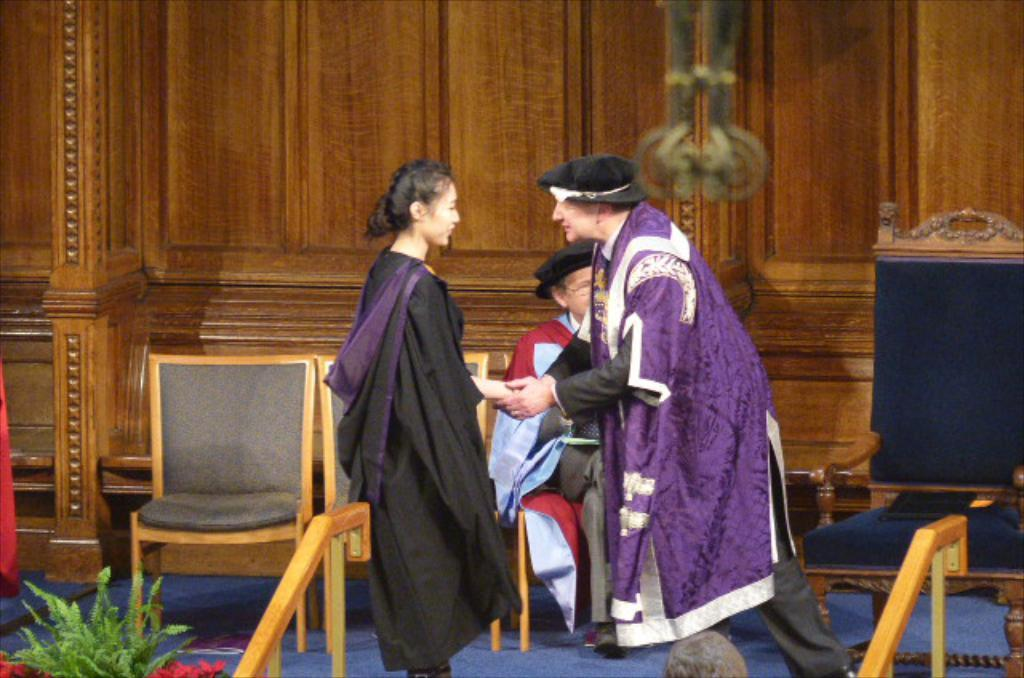How many people are on the stage in the image? There are three people on the stage in the image. What objects can be seen in the image besides the people on the stage? There are chairs and a houseplant visible in the image. What type of receipt can be seen in the hands of the people on the stage? There is no receipt present in the image; the people on the stage are not holding any objects. 